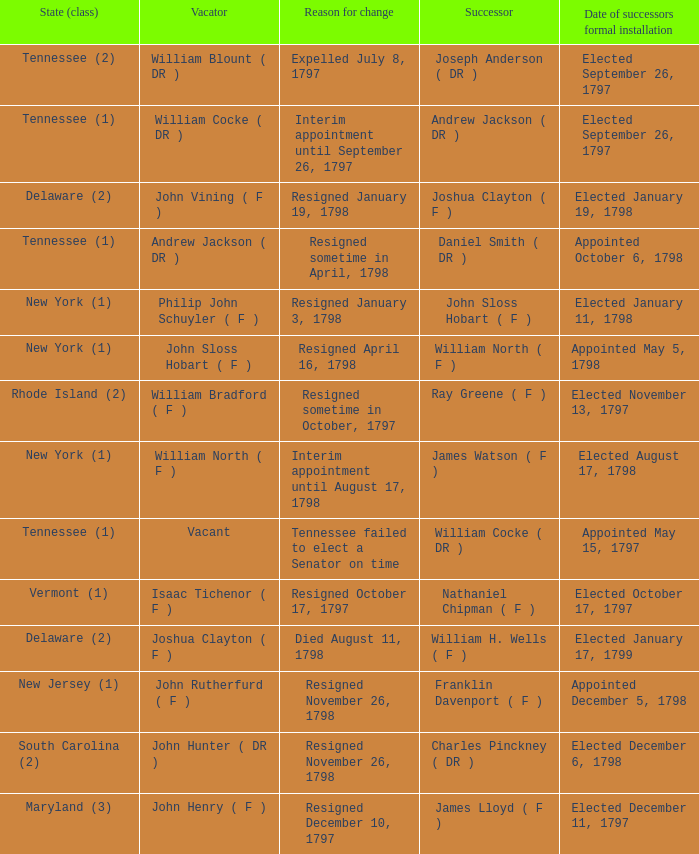What are all the states (class) when the reason for change was resigned November 26, 1798 and the vacator was John Hunter ( DR )? South Carolina (2). 